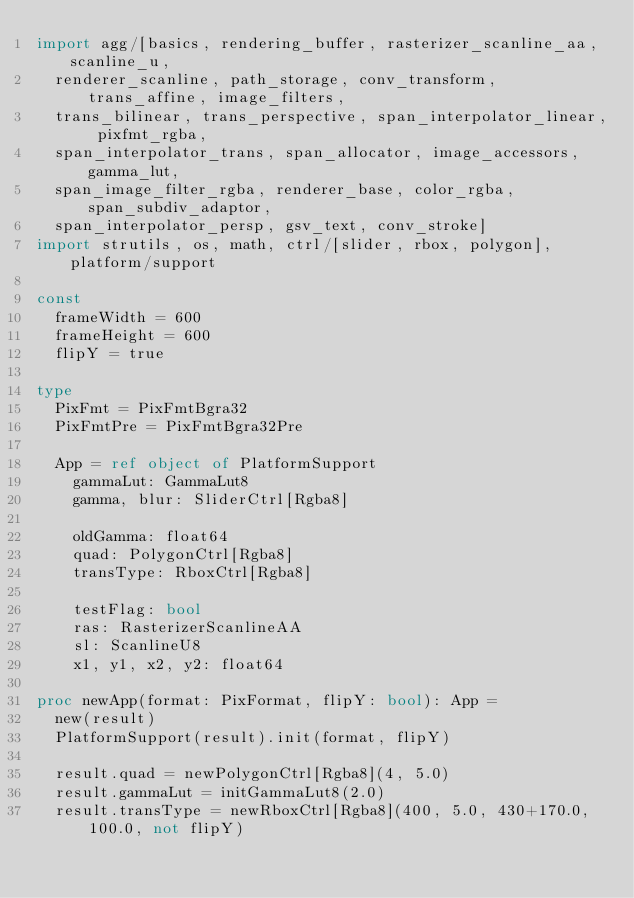Convert code to text. <code><loc_0><loc_0><loc_500><loc_500><_Nim_>import agg/[basics, rendering_buffer, rasterizer_scanline_aa, scanline_u,
  renderer_scanline, path_storage, conv_transform, trans_affine, image_filters,
  trans_bilinear, trans_perspective, span_interpolator_linear, pixfmt_rgba,
  span_interpolator_trans, span_allocator, image_accessors, gamma_lut,
  span_image_filter_rgba, renderer_base, color_rgba, span_subdiv_adaptor,
  span_interpolator_persp, gsv_text, conv_stroke]
import strutils, os, math, ctrl/[slider, rbox, polygon], platform/support

const
  frameWidth = 600
  frameHeight = 600
  flipY = true

type
  PixFmt = PixFmtBgra32
  PixFmtPre = PixFmtBgra32Pre

  App = ref object of PlatformSupport
    gammaLut: GammaLut8
    gamma, blur: SliderCtrl[Rgba8]

    oldGamma: float64
    quad: PolygonCtrl[Rgba8]
    transType: RboxCtrl[Rgba8]

    testFlag: bool
    ras: RasterizerScanlineAA
    sl: ScanlineU8
    x1, y1, x2, y2: float64

proc newApp(format: PixFormat, flipY: bool): App =
  new(result)
  PlatformSupport(result).init(format, flipY)

  result.quad = newPolygonCtrl[Rgba8](4, 5.0)
  result.gammaLut = initGammaLut8(2.0)
  result.transType = newRboxCtrl[Rgba8](400, 5.0, 430+170.0, 100.0, not flipY)</code> 